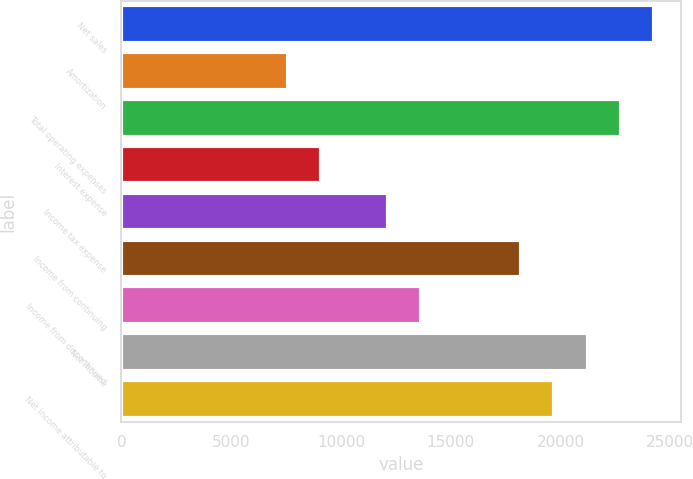Convert chart to OTSL. <chart><loc_0><loc_0><loc_500><loc_500><bar_chart><fcel>Net sales<fcel>Amortization<fcel>Total operating expenses<fcel>Interest expense<fcel>Income tax expense<fcel>Income from continuing<fcel>Income from discontinued<fcel>Net income<fcel>Net income attributable to<nl><fcel>24263.5<fcel>7582.97<fcel>22747.1<fcel>9099.38<fcel>12132.2<fcel>18197.8<fcel>13648.6<fcel>21230.7<fcel>19714.2<nl></chart> 